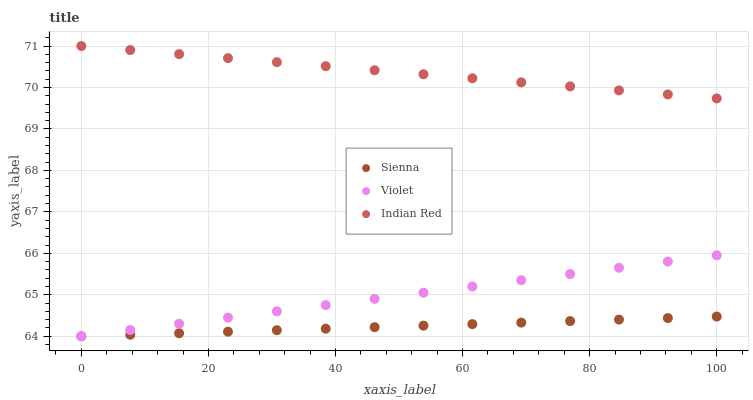Does Sienna have the minimum area under the curve?
Answer yes or no. Yes. Does Indian Red have the maximum area under the curve?
Answer yes or no. Yes. Does Violet have the minimum area under the curve?
Answer yes or no. No. Does Violet have the maximum area under the curve?
Answer yes or no. No. Is Indian Red the smoothest?
Answer yes or no. Yes. Is Violet the roughest?
Answer yes or no. Yes. Is Violet the smoothest?
Answer yes or no. No. Is Indian Red the roughest?
Answer yes or no. No. Does Sienna have the lowest value?
Answer yes or no. Yes. Does Indian Red have the lowest value?
Answer yes or no. No. Does Indian Red have the highest value?
Answer yes or no. Yes. Does Violet have the highest value?
Answer yes or no. No. Is Sienna less than Indian Red?
Answer yes or no. Yes. Is Indian Red greater than Sienna?
Answer yes or no. Yes. Does Violet intersect Sienna?
Answer yes or no. Yes. Is Violet less than Sienna?
Answer yes or no. No. Is Violet greater than Sienna?
Answer yes or no. No. Does Sienna intersect Indian Red?
Answer yes or no. No. 